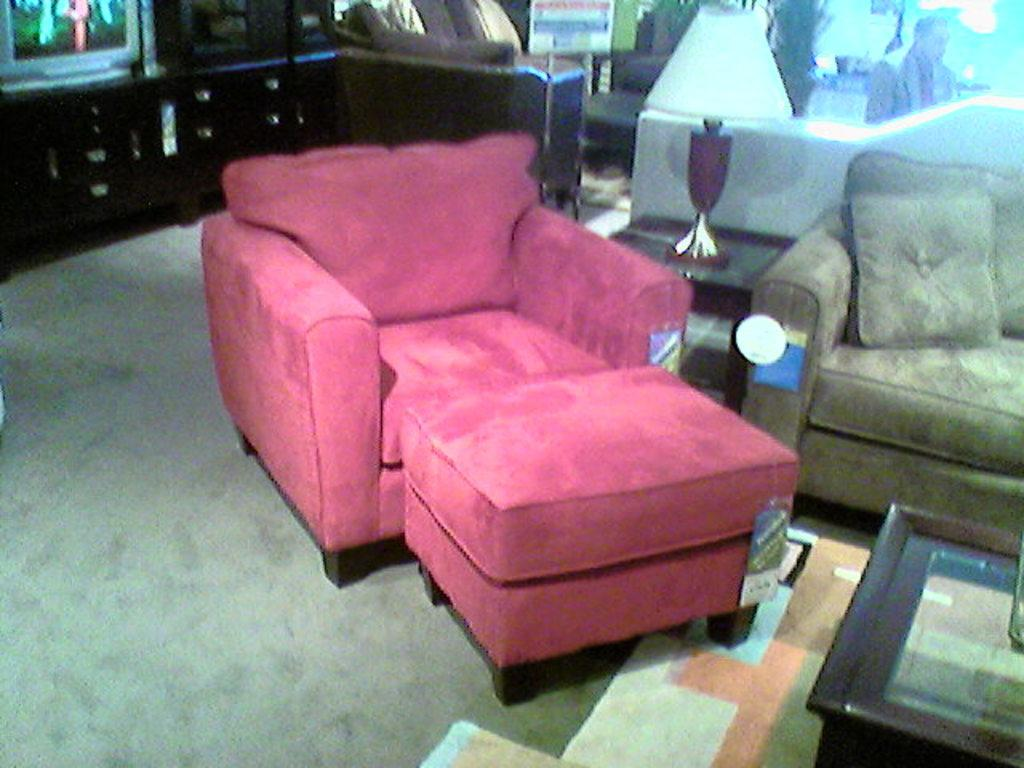What type of electronic device is present in the image? There is a television in the image. What type of furniture is present in the image? There is a sofa in the image. What type of lighting fixture is present in the image? There is a lamp in the image. What type of accessory is present in the image? There is a pillow in the image. What type of glue is being used to hold the television in the image? There is no glue present in the image, and the television is not being held in place by any adhesive. Can you see an uncle in the image? There is no uncle present in the image. 